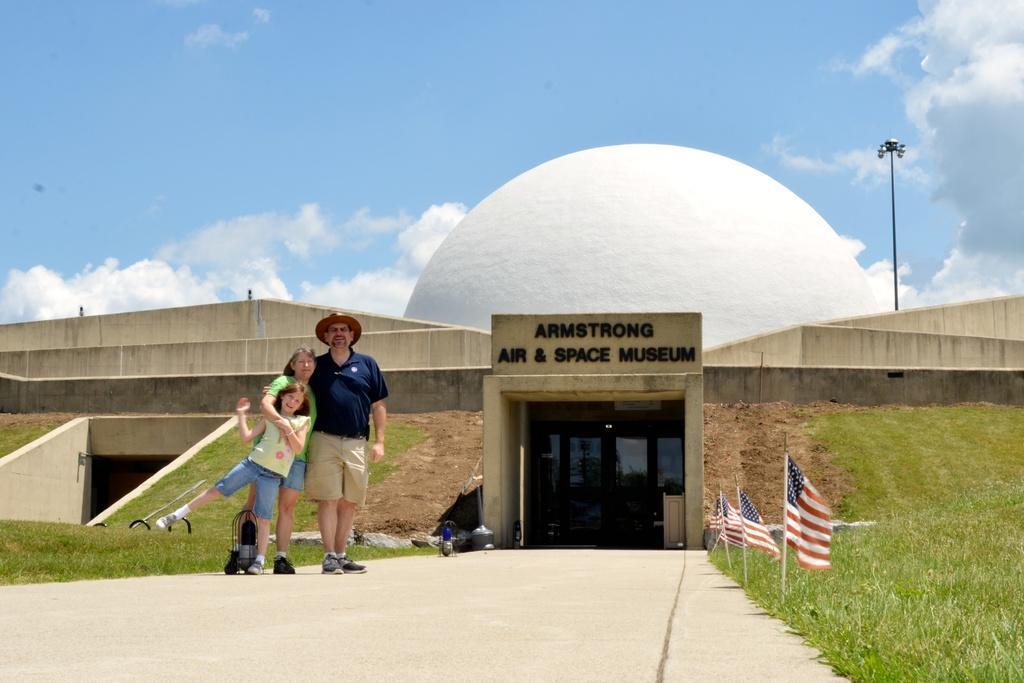How would you summarize this image in a sentence or two? In this image I can see a person wearing black and cream colored dress and a woman wearing green and blue colored dress and a child are standing on the road. I can see some grass on both sides of the road, few flags and the bridge. In the background I can see the white colored buildings, a light pole and the sky. 